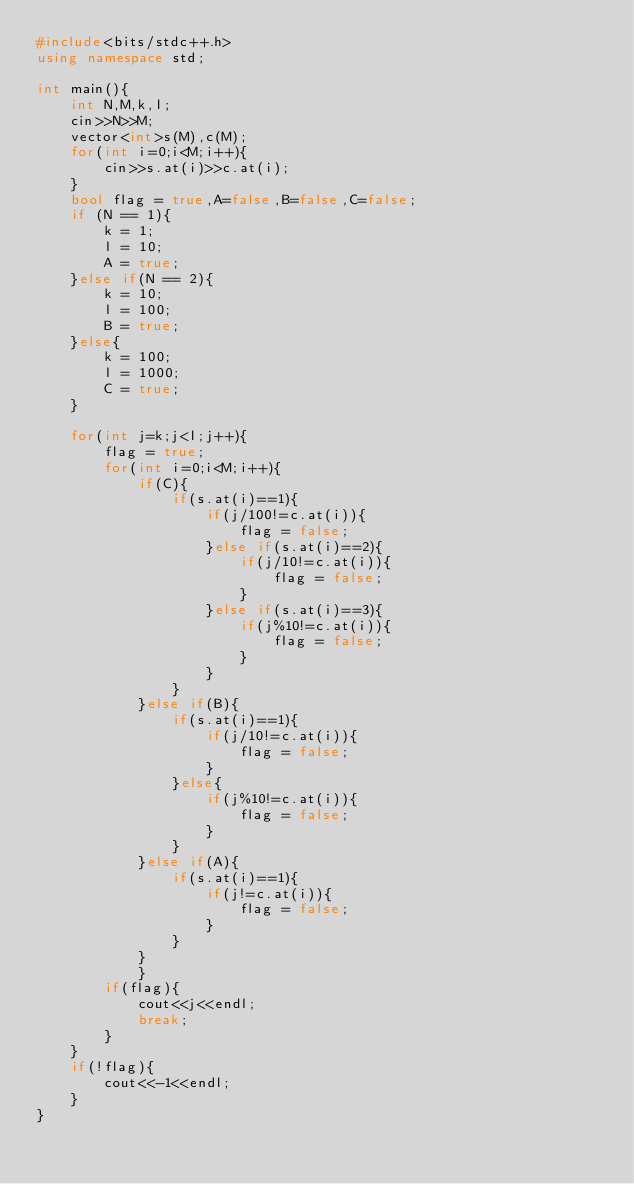Convert code to text. <code><loc_0><loc_0><loc_500><loc_500><_C++_>#include<bits/stdc++.h>
using namespace std;

int main(){
    int N,M,k,l;
    cin>>N>>M;
    vector<int>s(M),c(M);
    for(int i=0;i<M;i++){
        cin>>s.at(i)>>c.at(i);
    }
    bool flag = true,A=false,B=false,C=false;
    if (N == 1){
        k = 1;
        l = 10;
        A = true;
    }else if(N == 2){
        k = 10;
        l = 100;
        B = true;
    }else{
        k = 100;
        l = 1000;
        C = true;
    }
    
    for(int j=k;j<l;j++){
        flag = true;
        for(int i=0;i<M;i++){
            if(C){
                if(s.at(i)==1){
                    if(j/100!=c.at(i)){
                        flag = false;
                    }else if(s.at(i)==2){
                        if(j/10!=c.at(i)){
                            flag = false;
                        }
                    }else if(s.at(i)==3){
                        if(j%10!=c.at(i)){
                            flag = false;
                        }
                    }
                }
            }else if(B){
                if(s.at(i)==1){
                    if(j/10!=c.at(i)){
                        flag = false;
                    }
                }else{
                    if(j%10!=c.at(i)){
                        flag = false;
                    }
                }
            }else if(A){
                if(s.at(i)==1){
                    if(j!=c.at(i)){
                        flag = false;
                    }
                }
            }
            }
        if(flag){
            cout<<j<<endl;
            break;
        }
    }
    if(!flag){
        cout<<-1<<endl;
    }
}</code> 